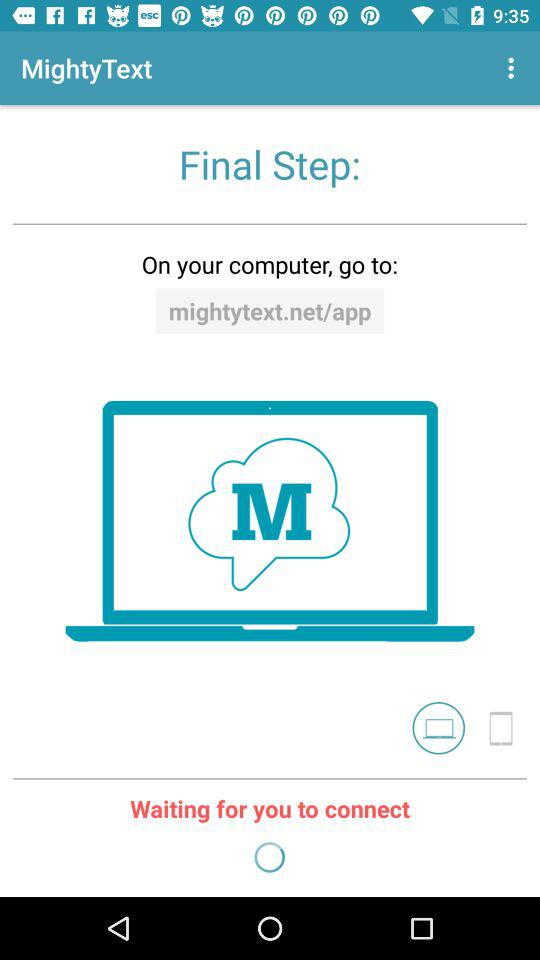What is the name of the application? The application name is "MightyText". 